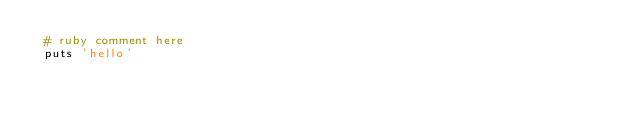Convert code to text. <code><loc_0><loc_0><loc_500><loc_500><_Ruby_> # ruby comment here
 puts 'hello'
</code> 